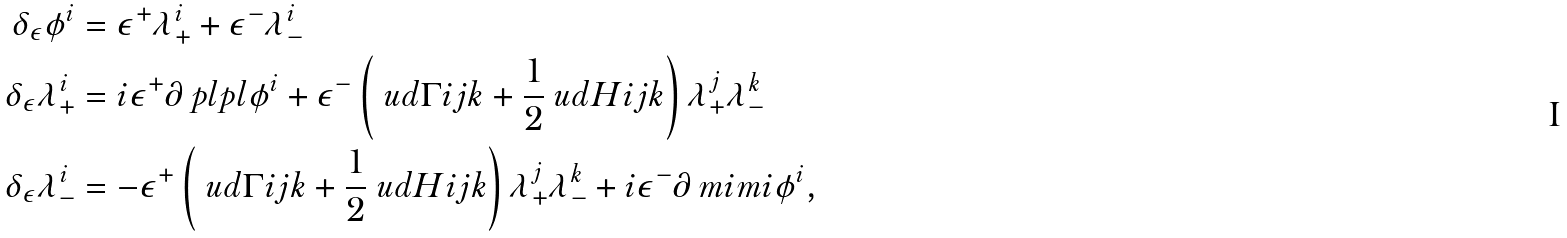<formula> <loc_0><loc_0><loc_500><loc_500>\delta _ { \epsilon } \phi ^ { i } & = \epsilon ^ { + } \lambda _ { + } ^ { i } + \epsilon ^ { - } \lambda _ { - } ^ { i } \\ \delta _ { \epsilon } \lambda _ { + } ^ { i } & = i \epsilon ^ { + } \partial _ { \ } p l p l \phi ^ { i } + \epsilon ^ { - } \left ( \ u d \Gamma { i } { j k } + \frac { 1 } { 2 } \ u d H i { j k } \right ) \lambda _ { + } ^ { j } \lambda _ { - } ^ { k } \\ \delta _ { \epsilon } \lambda _ { - } ^ { i } & = - \epsilon ^ { + } \left ( \ u d \Gamma { i } { j k } + \frac { 1 } { 2 } \ u d H i { j k } \right ) \lambda _ { + } ^ { j } \lambda _ { - } ^ { k } + i \epsilon ^ { - } \partial _ { \ } m i m i \phi ^ { i } ,</formula> 